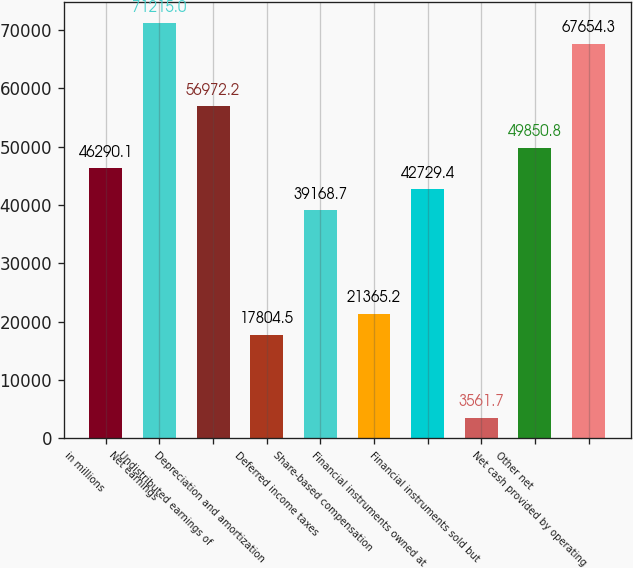Convert chart to OTSL. <chart><loc_0><loc_0><loc_500><loc_500><bar_chart><fcel>in millions<fcel>Net earnings<fcel>Undistributed earnings of<fcel>Depreciation and amortization<fcel>Deferred income taxes<fcel>Share-based compensation<fcel>Financial instruments owned at<fcel>Financial instruments sold but<fcel>Other net<fcel>Net cash provided by operating<nl><fcel>46290.1<fcel>71215<fcel>56972.2<fcel>17804.5<fcel>39168.7<fcel>21365.2<fcel>42729.4<fcel>3561.7<fcel>49850.8<fcel>67654.3<nl></chart> 